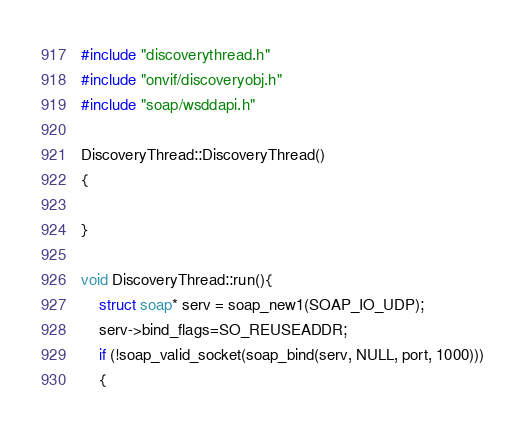Convert code to text. <code><loc_0><loc_0><loc_500><loc_500><_C++_>#include "discoverythread.h"
#include "onvif/discoveryobj.h"
#include "soap/wsddapi.h"

DiscoveryThread::DiscoveryThread()
{

}

void DiscoveryThread::run(){
    struct soap* serv = soap_new1(SOAP_IO_UDP);
    serv->bind_flags=SO_REUSEADDR;
    if (!soap_valid_socket(soap_bind(serv, NULL, port, 1000)))
    {</code> 